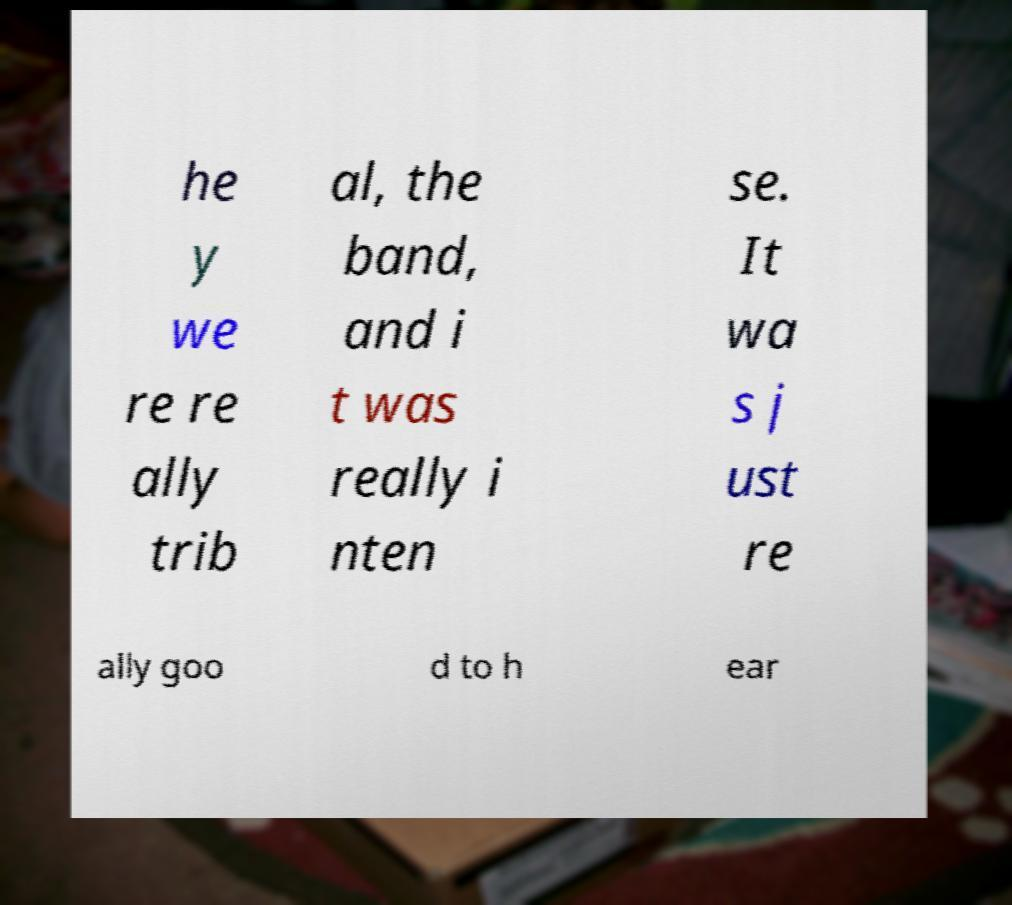For documentation purposes, I need the text within this image transcribed. Could you provide that? he y we re re ally trib al, the band, and i t was really i nten se. It wa s j ust re ally goo d to h ear 